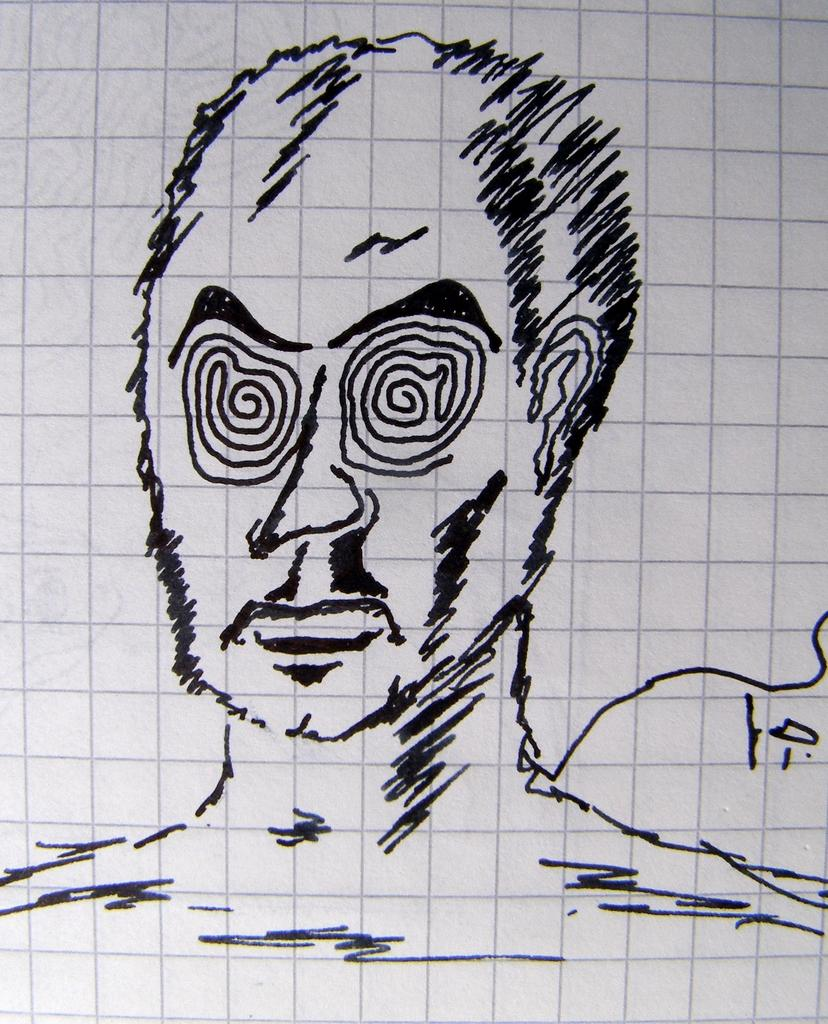What is depicted in the image? There is an art of a person's face in the image. What is the medium of the art? The art is on a paper. What color is the paper? The paper is white. How many cows are visible in the image? There are no cows present in the image. What type of material is the art made of in the image? The art is made on a paper, not on leather. 